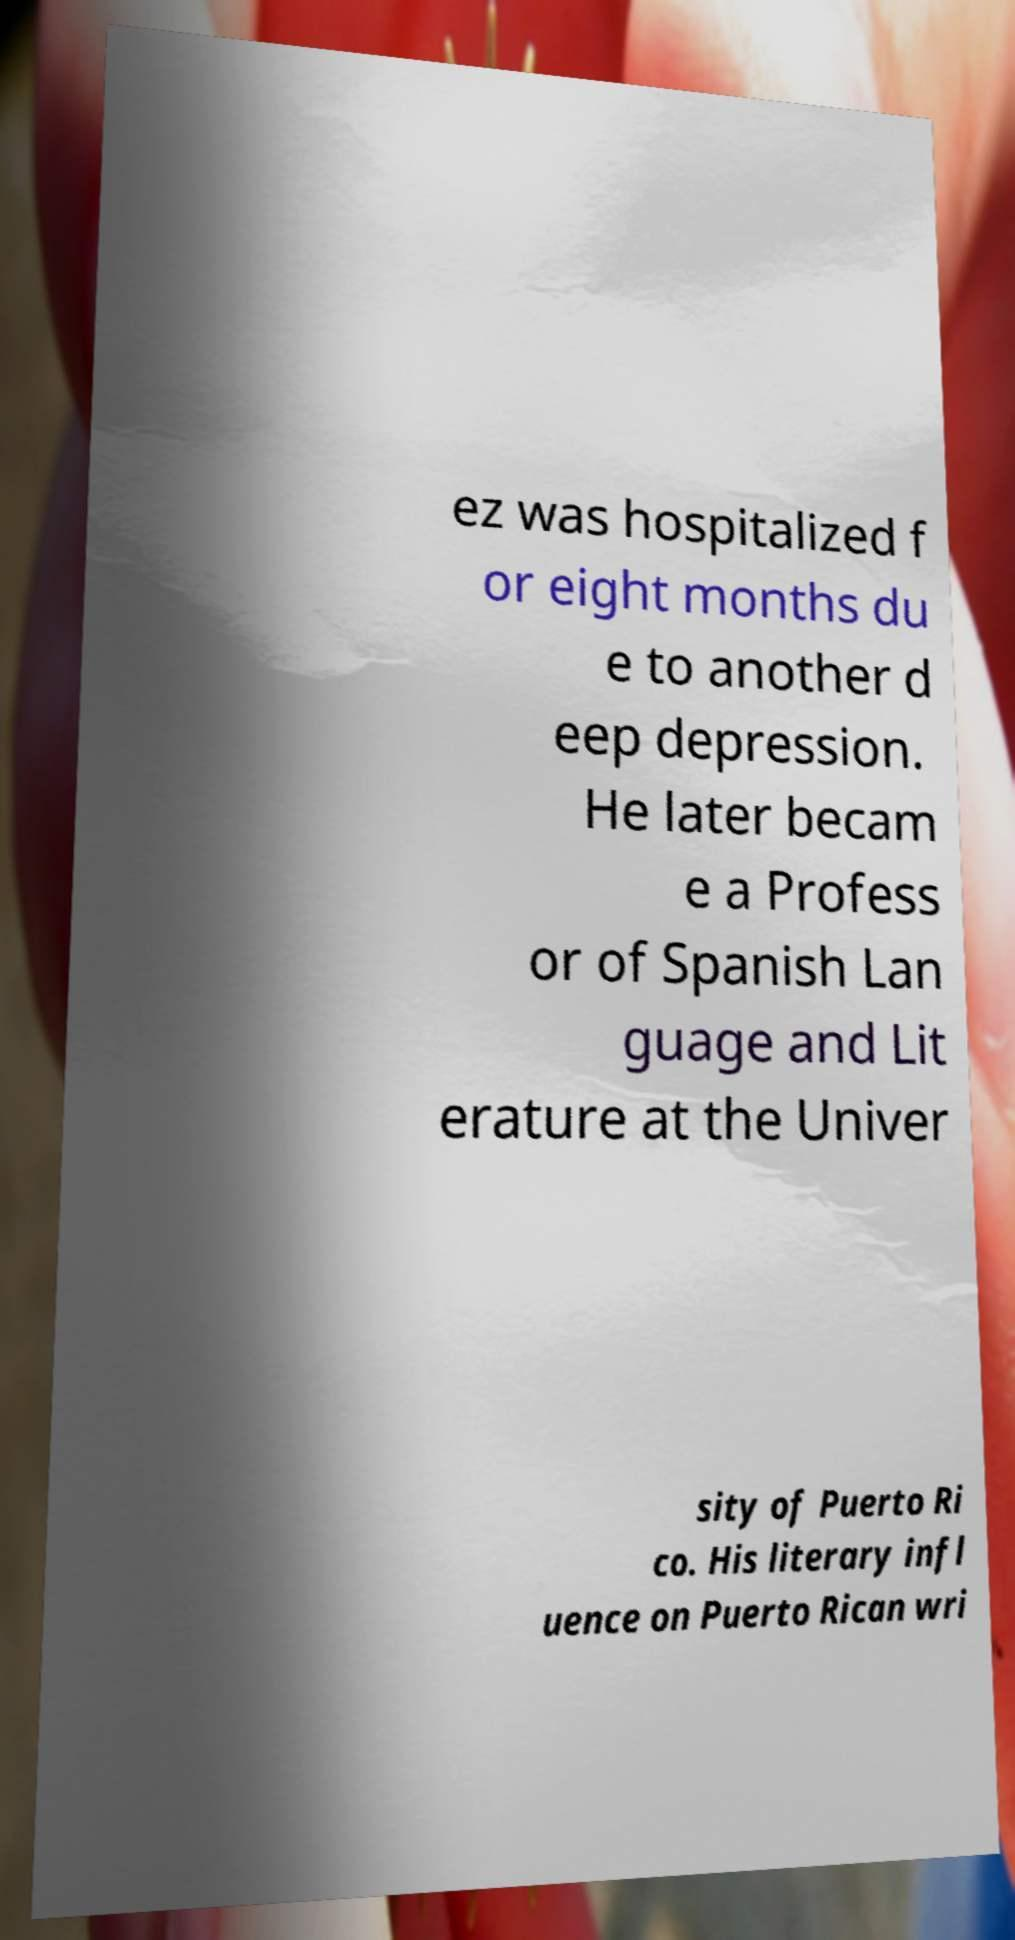I need the written content from this picture converted into text. Can you do that? ez was hospitalized f or eight months du e to another d eep depression. He later becam e a Profess or of Spanish Lan guage and Lit erature at the Univer sity of Puerto Ri co. His literary infl uence on Puerto Rican wri 